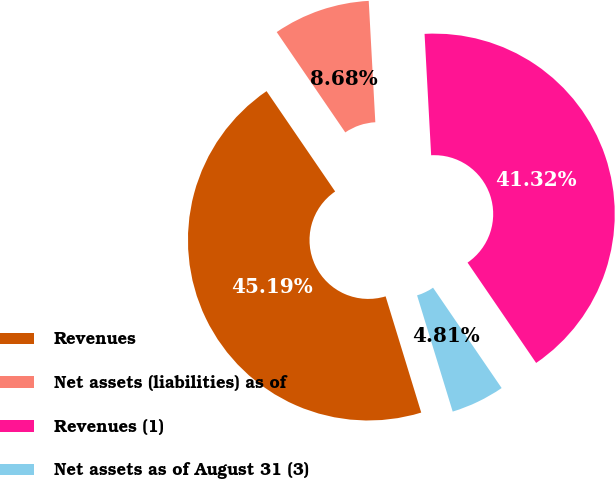Convert chart to OTSL. <chart><loc_0><loc_0><loc_500><loc_500><pie_chart><fcel>Revenues<fcel>Net assets (liabilities) as of<fcel>Revenues (1)<fcel>Net assets as of August 31 (3)<nl><fcel>45.19%<fcel>8.68%<fcel>41.32%<fcel>4.81%<nl></chart> 